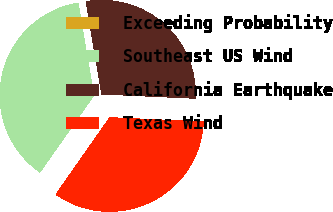Convert chart. <chart><loc_0><loc_0><loc_500><loc_500><pie_chart><fcel>Exceeding Probability<fcel>Southeast US Wind<fcel>California Earthquake<fcel>Texas Wind<nl><fcel>0.0%<fcel>37.6%<fcel>28.39%<fcel>34.0%<nl></chart> 